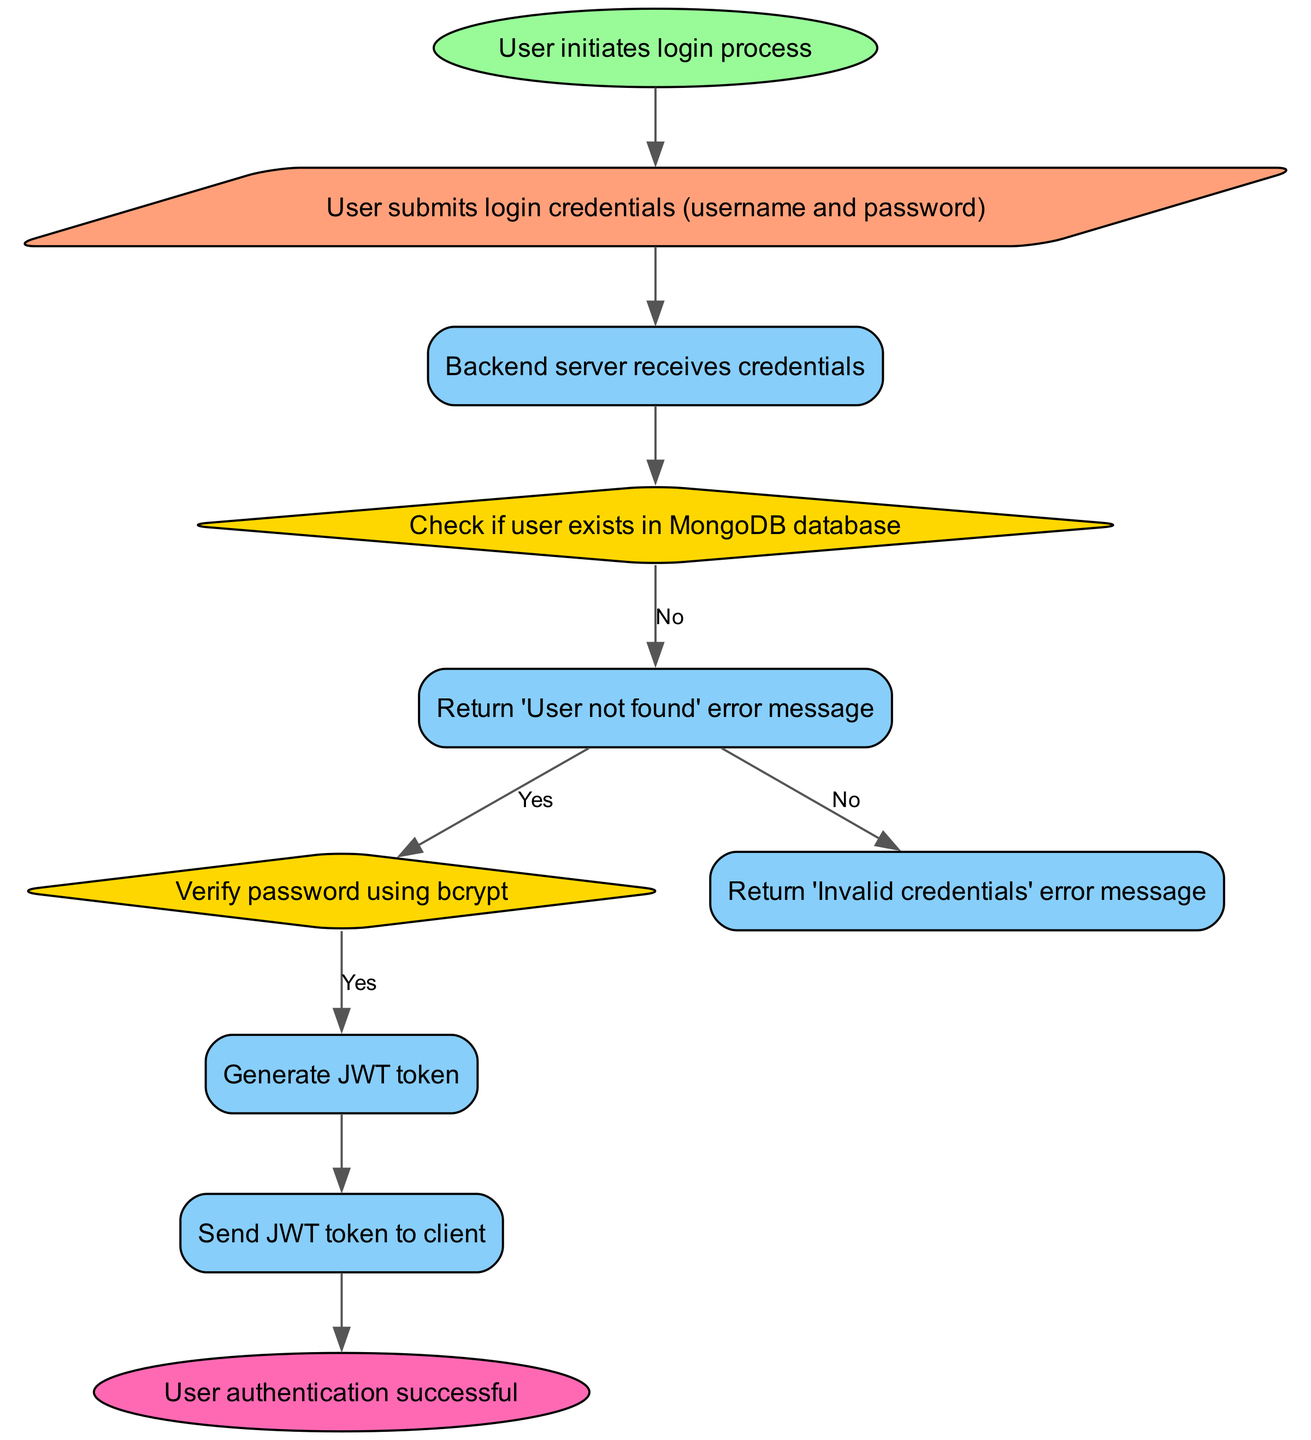What initiates the user authentication process? The flowchart starts with a user action, specifically when the user initiates the login process, which is captured as the first element in the diagram.
Answer: User initiates login process What type of input does the user provide during authentication? The diagram shows that the user submits login credentials which specifically are the username and password, appearing as the second element in the flowchart.
Answer: Login credentials (username and password) How many decision nodes are present in the diagram? By counting the decision elements in the diagram, we can see there are two decision nodes: one to check if the user exists and another to verify the password.
Answer: Two What happens if the user is not found in the database? According to the flowchart, if the user is not found, a 'User not found' error message is returned, which is depicted in the corresponding process node for the 'UserNotFound' path.
Answer: Return 'User not found' error message What process occurs after verifying the password is correct? The flowchart indicates that if the password is verified as correct, the next step is to generate a JWT token, which is represented in the process node following the password check.
Answer: Generate JWT token What is the final outcome of the authentication process? The diagram ends with an element that states the user authentication was successful, marking the completion of the flowchart process.
Answer: User authentication successful How does the flow transition from verifying the password to sending feedback to the client? Following the verification of the password, if the password is correct, the JWT token is generated, and then this token is subsequently sent to the client, illustrating a clear transition of process steps.
Answer: Send JWT token to client What is the purpose of using bcrypt in this flow? The diagram specifies that bcrypt is used to verify the password, which ensures that the password provided by the user can be securely matched against the stored hash in the database, adding a layer of security to the authentication process.
Answer: Verify password using bcrypt What happens if the password is incorrect? If the password verification fails, the flowchart indicates that an 'Invalid credentials' error message is returned to the user, highlighting the error handling mechanism in this process.
Answer: Return 'Invalid credentials' error message 